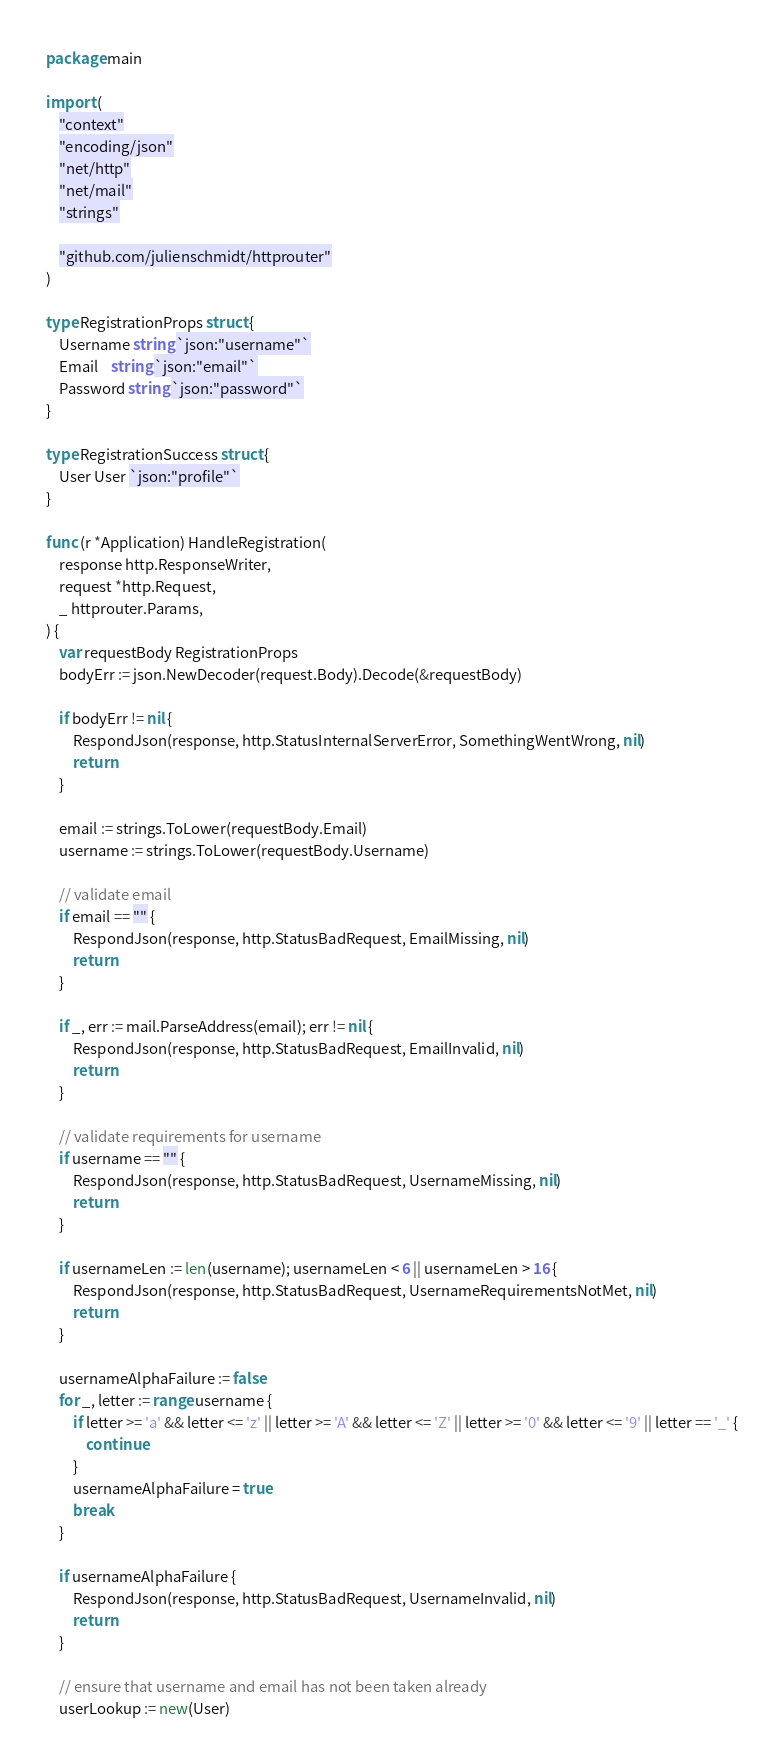<code> <loc_0><loc_0><loc_500><loc_500><_Go_>package main

import (
	"context"
	"encoding/json"
	"net/http"
	"net/mail"
	"strings"

	"github.com/julienschmidt/httprouter"
)

type RegistrationProps struct {
	Username string `json:"username"`
	Email    string `json:"email"`
	Password string `json:"password"`
}

type RegistrationSuccess struct {
	User User `json:"profile"`
}

func (r *Application) HandleRegistration(
	response http.ResponseWriter,
	request *http.Request,
	_ httprouter.Params,
) {
	var requestBody RegistrationProps
	bodyErr := json.NewDecoder(request.Body).Decode(&requestBody)

	if bodyErr != nil {
		RespondJson(response, http.StatusInternalServerError, SomethingWentWrong, nil)
		return
	}

	email := strings.ToLower(requestBody.Email)
	username := strings.ToLower(requestBody.Username)

	// validate email
	if email == "" {
		RespondJson(response, http.StatusBadRequest, EmailMissing, nil)
		return
	}

	if _, err := mail.ParseAddress(email); err != nil {
		RespondJson(response, http.StatusBadRequest, EmailInvalid, nil)
		return
	}

	// validate requirements for username
	if username == "" {
		RespondJson(response, http.StatusBadRequest, UsernameMissing, nil)
		return
	}

	if usernameLen := len(username); usernameLen < 6 || usernameLen > 16 {
		RespondJson(response, http.StatusBadRequest, UsernameRequirementsNotMet, nil)
		return
	}

	usernameAlphaFailure := false
	for _, letter := range username {
		if letter >= 'a' && letter <= 'z' || letter >= 'A' && letter <= 'Z' || letter >= '0' && letter <= '9' || letter == '_' {
			continue
		}
		usernameAlphaFailure = true
		break
	}

	if usernameAlphaFailure {
		RespondJson(response, http.StatusBadRequest, UsernameInvalid, nil)
		return
	}

	// ensure that username and email has not been taken already
	userLookup := new(User)</code> 